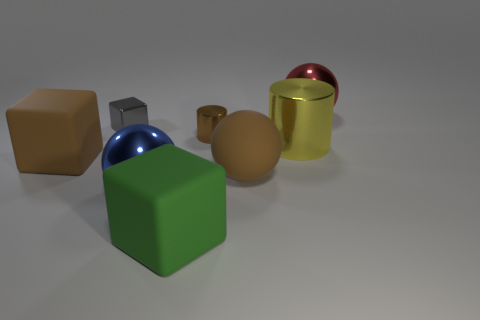There is a cylinder behind the large yellow object; is its color the same as the big rubber ball?
Provide a succinct answer. Yes. Does the red thing have the same material as the green block?
Keep it short and to the point. No. Are there an equal number of big rubber spheres that are to the right of the big brown sphere and big blue objects to the right of the large yellow object?
Keep it short and to the point. Yes. What material is the big red object that is the same shape as the blue metal object?
Keep it short and to the point. Metal. There is a big matte object that is in front of the big brown matte object that is in front of the big cube left of the shiny block; what is its shape?
Give a very brief answer. Cube. Are there more tiny things right of the gray cube than big yellow metallic cubes?
Give a very brief answer. Yes. Is the shape of the large brown matte object that is on the right side of the blue metallic thing the same as  the red shiny thing?
Provide a short and direct response. Yes. What is the small object on the right side of the blue object made of?
Make the answer very short. Metal. What number of tiny brown objects have the same shape as the big yellow metal object?
Provide a succinct answer. 1. What material is the block that is in front of the big cube behind the large blue shiny object made of?
Provide a short and direct response. Rubber. 